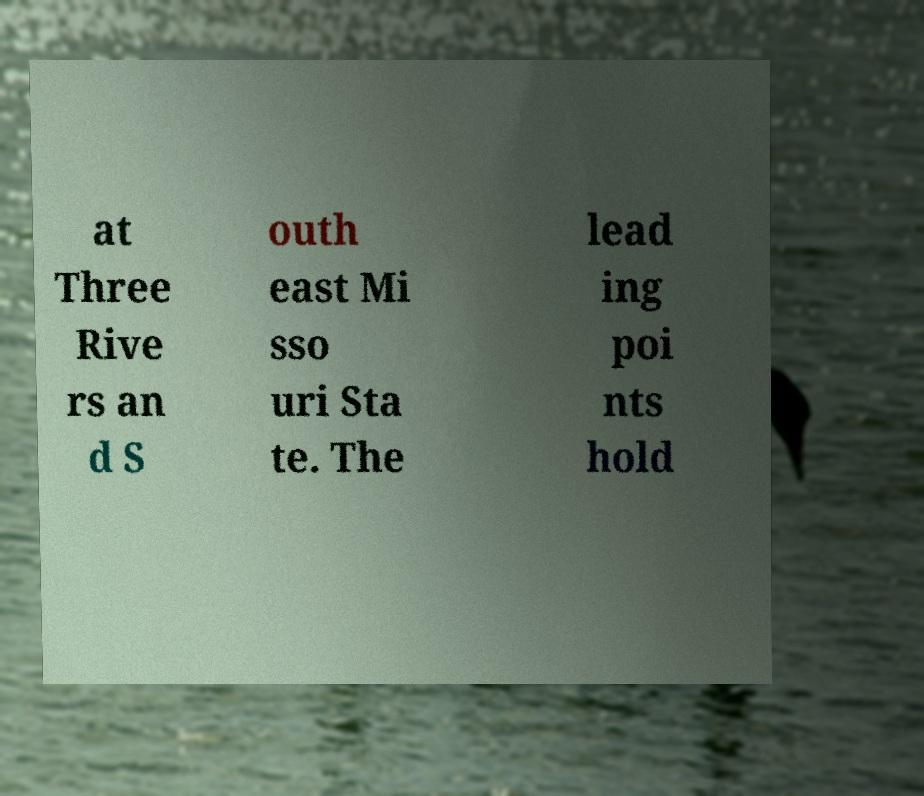Can you accurately transcribe the text from the provided image for me? at Three Rive rs an d S outh east Mi sso uri Sta te. The lead ing poi nts hold 